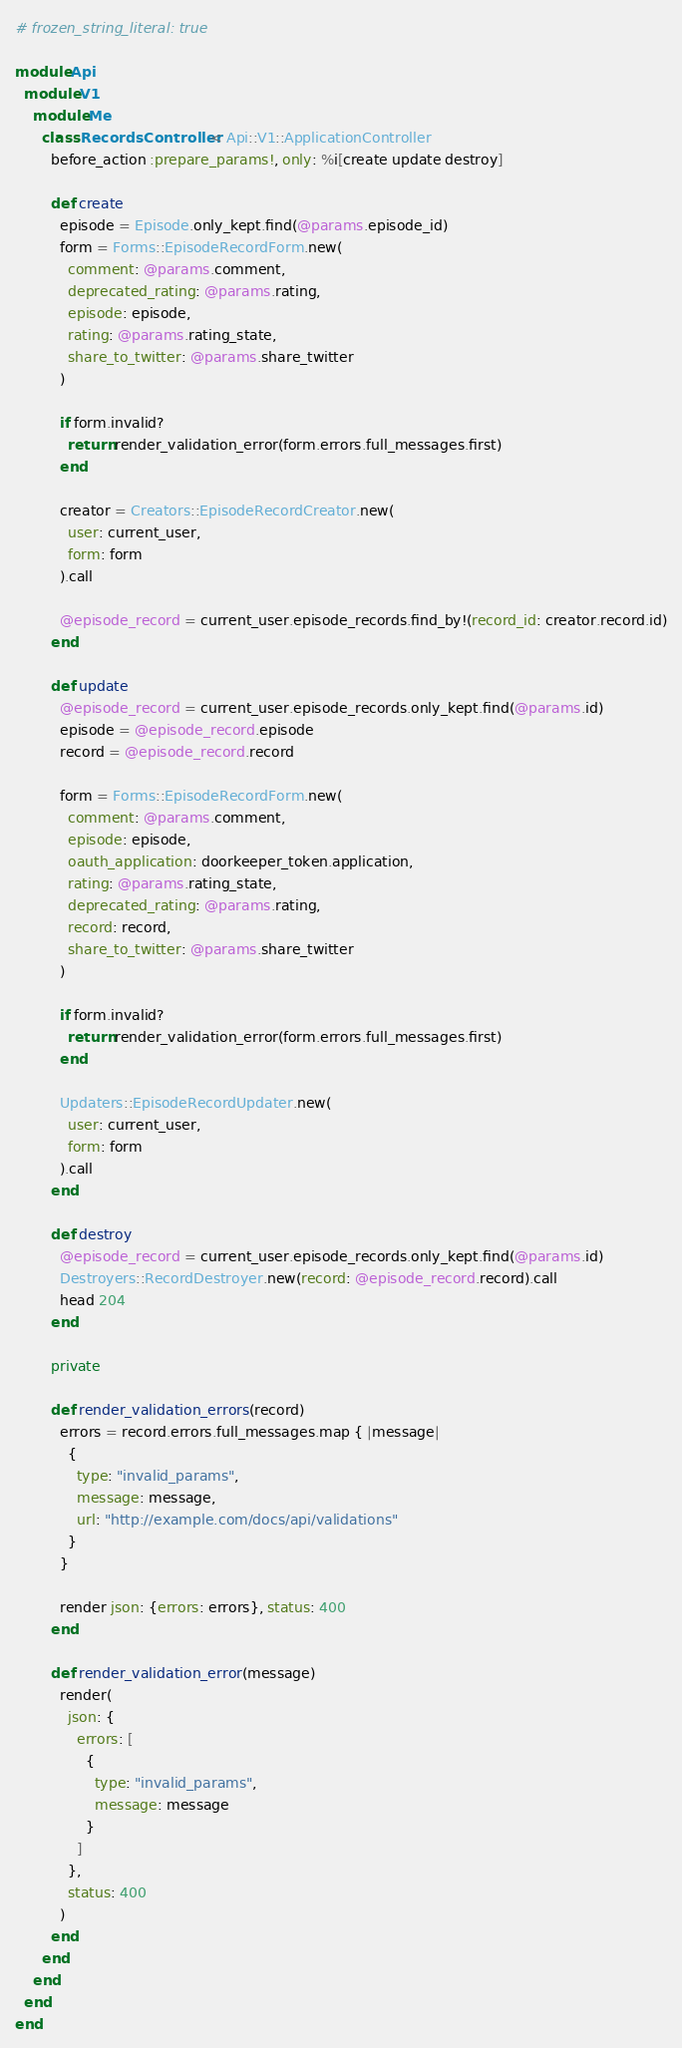<code> <loc_0><loc_0><loc_500><loc_500><_Ruby_># frozen_string_literal: true

module Api
  module V1
    module Me
      class RecordsController < Api::V1::ApplicationController
        before_action :prepare_params!, only: %i[create update destroy]

        def create
          episode = Episode.only_kept.find(@params.episode_id)
          form = Forms::EpisodeRecordForm.new(
            comment: @params.comment,
            deprecated_rating: @params.rating,
            episode: episode,
            rating: @params.rating_state,
            share_to_twitter: @params.share_twitter
          )

          if form.invalid?
            return render_validation_error(form.errors.full_messages.first)
          end

          creator = Creators::EpisodeRecordCreator.new(
            user: current_user,
            form: form
          ).call

          @episode_record = current_user.episode_records.find_by!(record_id: creator.record.id)
        end

        def update
          @episode_record = current_user.episode_records.only_kept.find(@params.id)
          episode = @episode_record.episode
          record = @episode_record.record

          form = Forms::EpisodeRecordForm.new(
            comment: @params.comment,
            episode: episode,
            oauth_application: doorkeeper_token.application,
            rating: @params.rating_state,
            deprecated_rating: @params.rating,
            record: record,
            share_to_twitter: @params.share_twitter
          )

          if form.invalid?
            return render_validation_error(form.errors.full_messages.first)
          end

          Updaters::EpisodeRecordUpdater.new(
            user: current_user,
            form: form
          ).call
        end

        def destroy
          @episode_record = current_user.episode_records.only_kept.find(@params.id)
          Destroyers::RecordDestroyer.new(record: @episode_record.record).call
          head 204
        end

        private

        def render_validation_errors(record)
          errors = record.errors.full_messages.map { |message|
            {
              type: "invalid_params",
              message: message,
              url: "http://example.com/docs/api/validations"
            }
          }

          render json: {errors: errors}, status: 400
        end

        def render_validation_error(message)
          render(
            json: {
              errors: [
                {
                  type: "invalid_params",
                  message: message
                }
              ]
            },
            status: 400
          )
        end
      end
    end
  end
end
</code> 